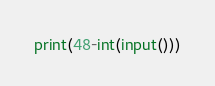Convert code to text. <code><loc_0><loc_0><loc_500><loc_500><_Python_>print(48-int(input()))</code> 